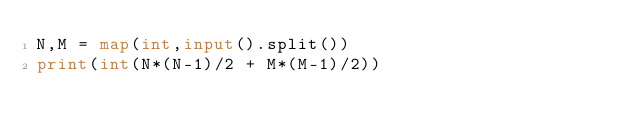<code> <loc_0><loc_0><loc_500><loc_500><_Python_>N,M = map(int,input().split())
print(int(N*(N-1)/2 + M*(M-1)/2))</code> 